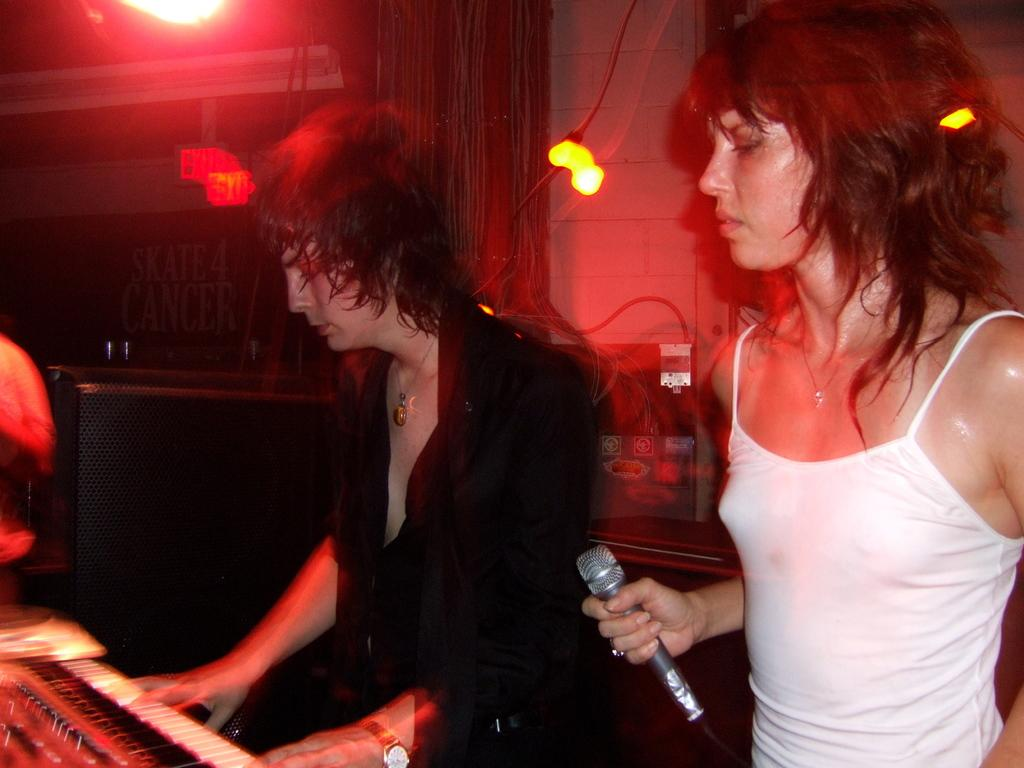How many people are in the image? There are two persons standing in the image. What are the people doing in the image? One person is playing a keyboard, and the other person is holding a microphone. What can be seen in the background of the image? There is a wall, lights, cables, and speakers visible in the background of the image. What type of reward is being given to the person holding the wrench in the image? There is no person holding a wrench in the image, and therefore no reward is being given. What rule is being enforced by the person holding the microphone in the image? There is no rule enforcement happening in the image; the person holding the microphone is likely singing or speaking into it. 